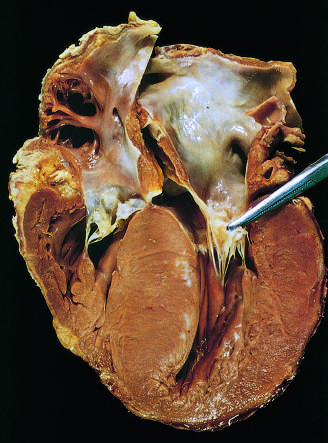s a liver enlarged?
Answer the question using a single word or phrase. No 